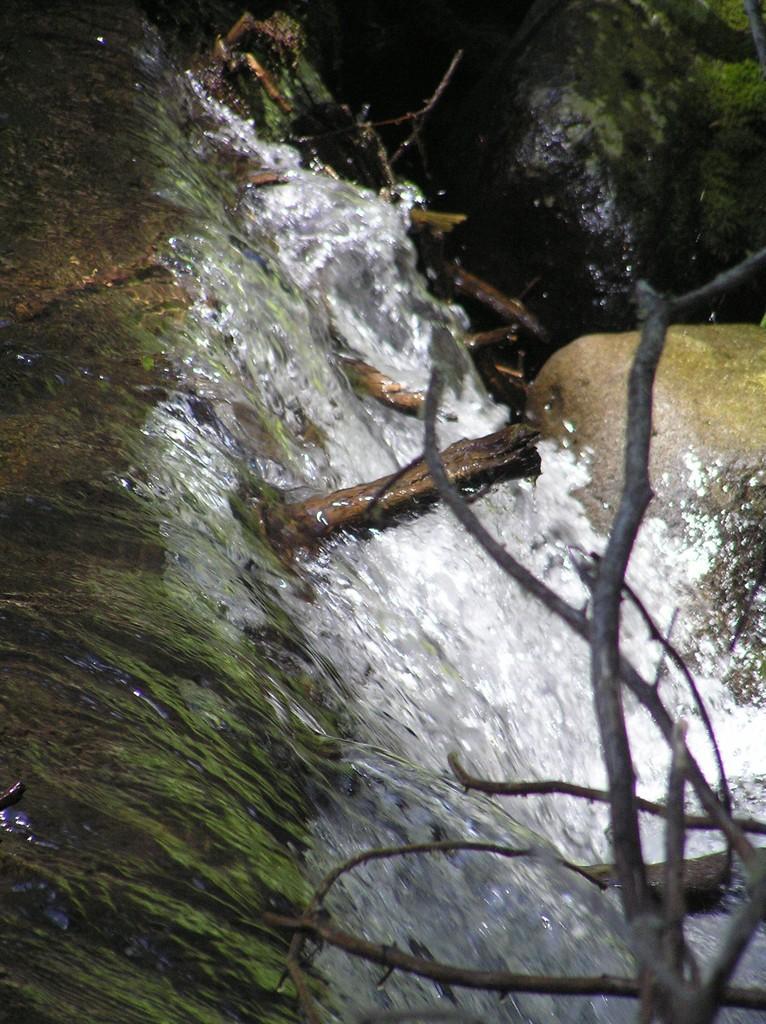In one or two sentences, can you explain what this image depicts? In this picture there is water flowing from the stones. At the bottom right there are sticks. 